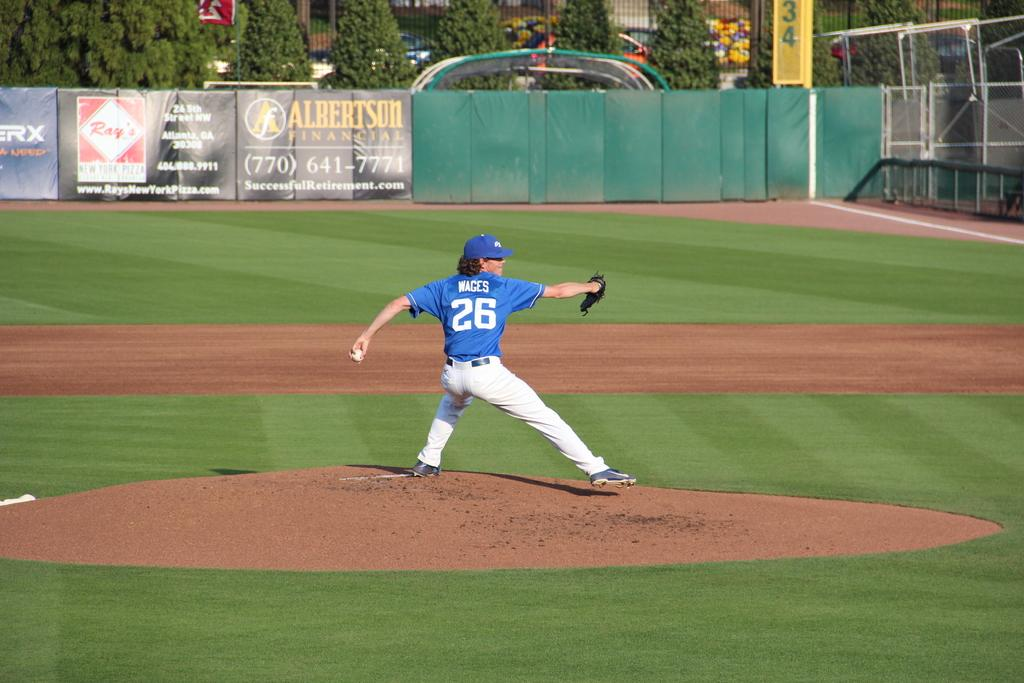<image>
Present a compact description of the photo's key features. A pitcher, named Wages, wears the jersey number 26. 